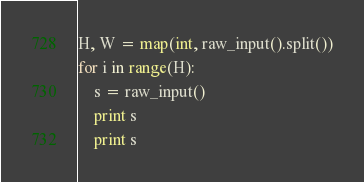Convert code to text. <code><loc_0><loc_0><loc_500><loc_500><_Python_>H, W = map(int, raw_input().split())
for i in range(H):
    s = raw_input()
    print s
    print s</code> 